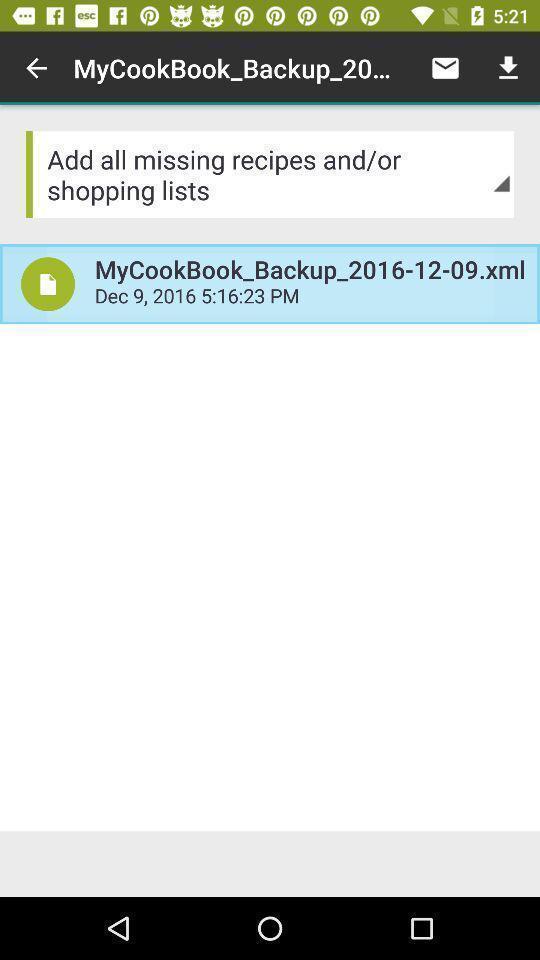Describe the key features of this screenshot. Screen displaying food recipes information with date and time. 